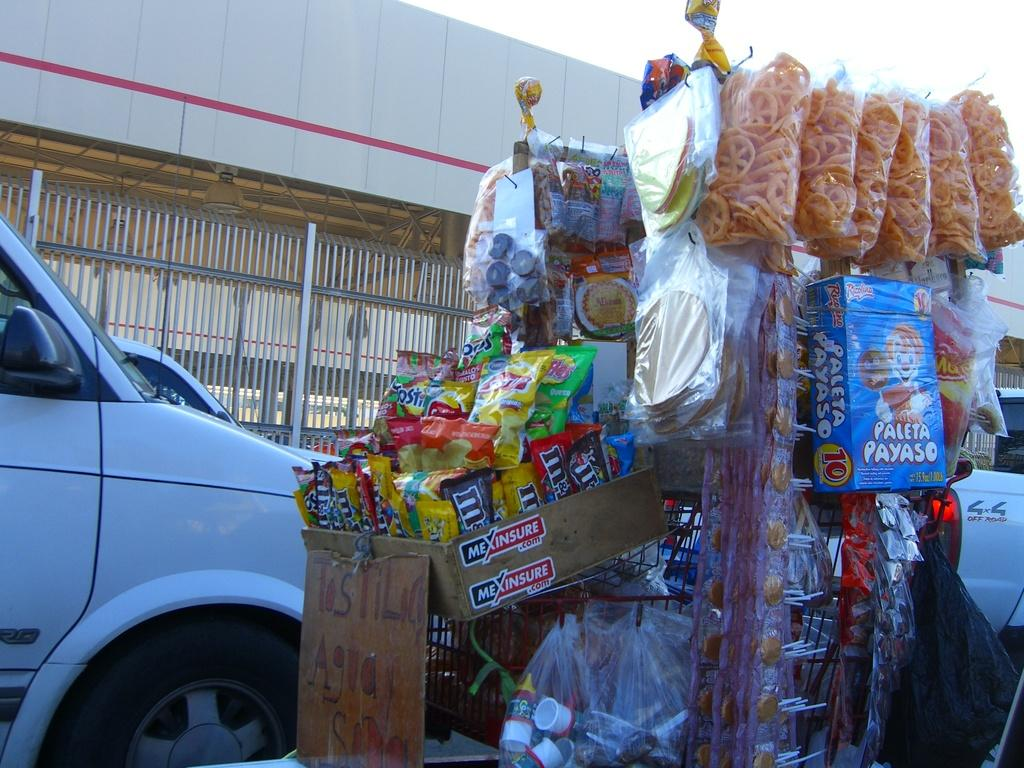What is placed on the object in the image? There are eatables placed on an object in the image. Can you describe the vehicles in the left corner of the image? There are two vehicles in the left corner of the image. What type of clover can be seen growing near the vehicles in the image? There is no clover present in the image; it only features eatables placed on an object and two vehicles in the left corner. How many twigs are visible in the image? There is no mention of twigs in the provided facts, so it cannot be determined from the image. 